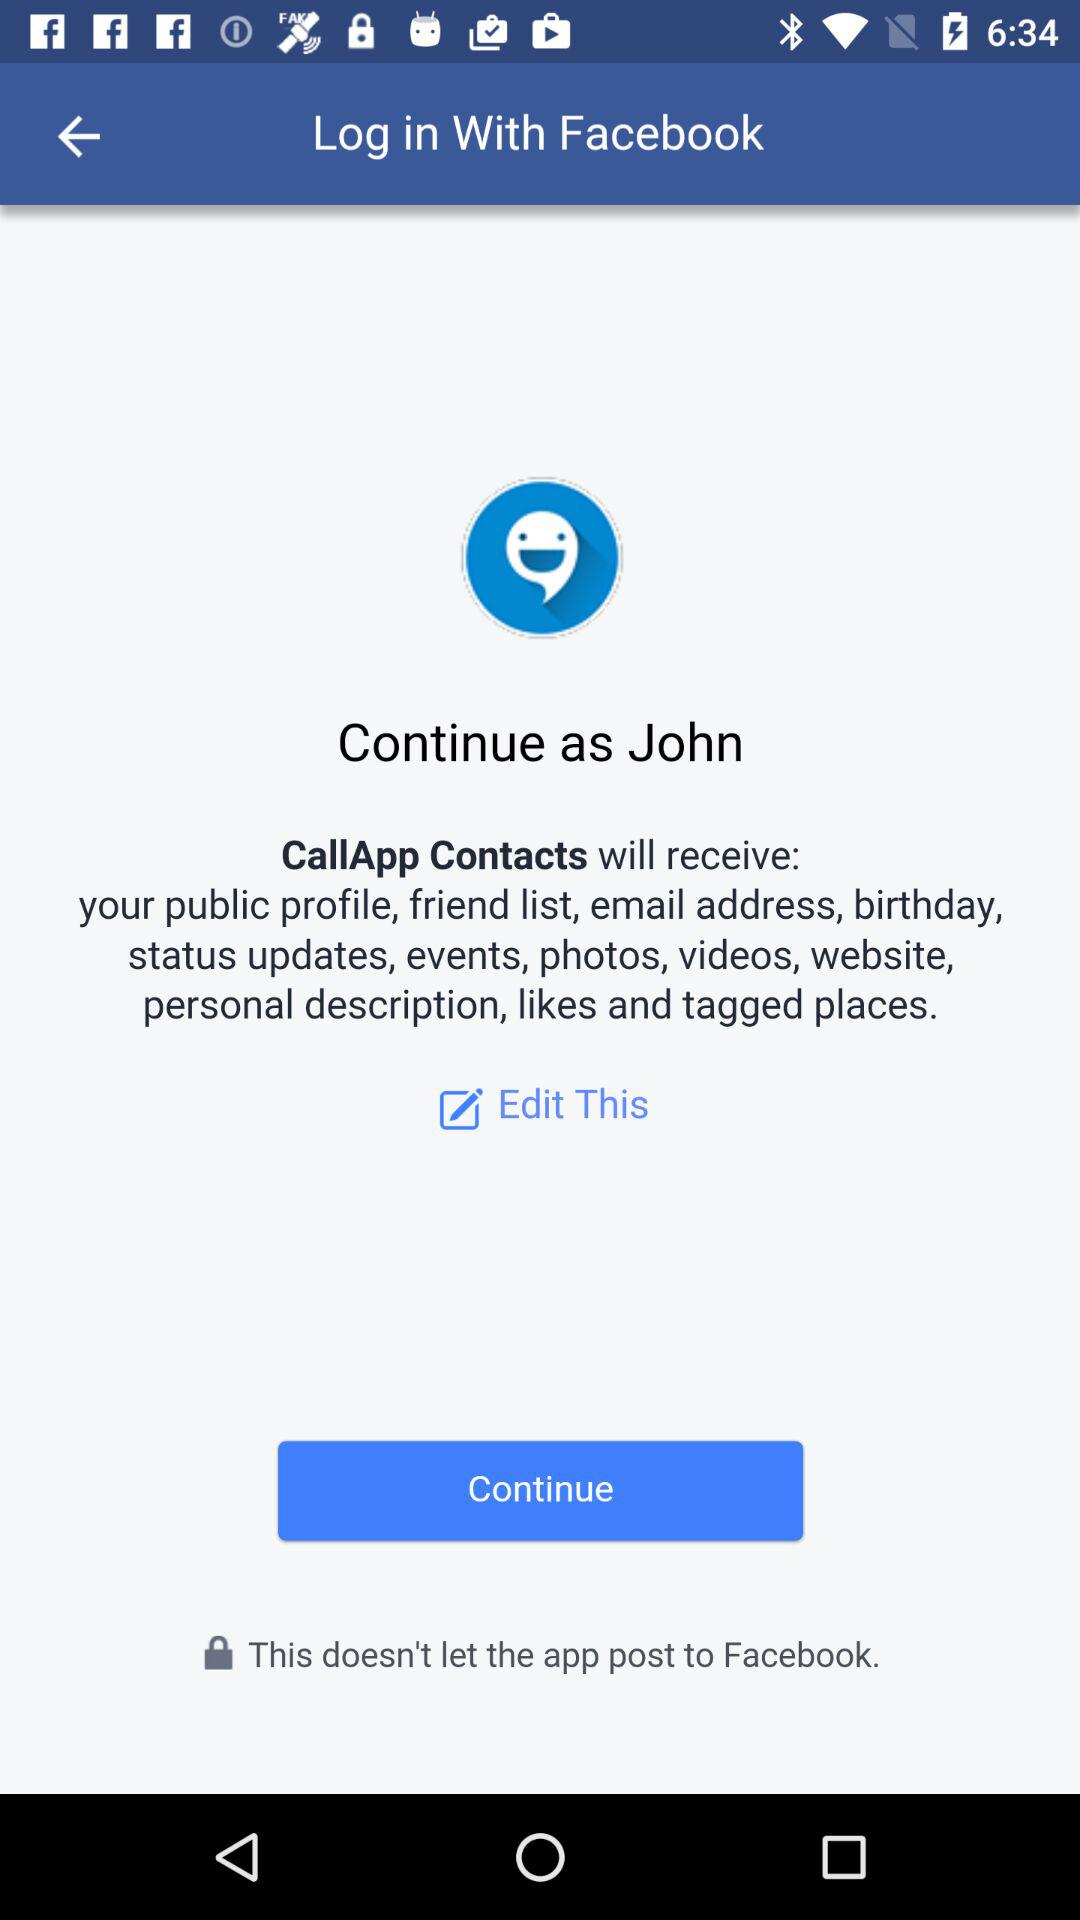What is the user name? The user name is John. 